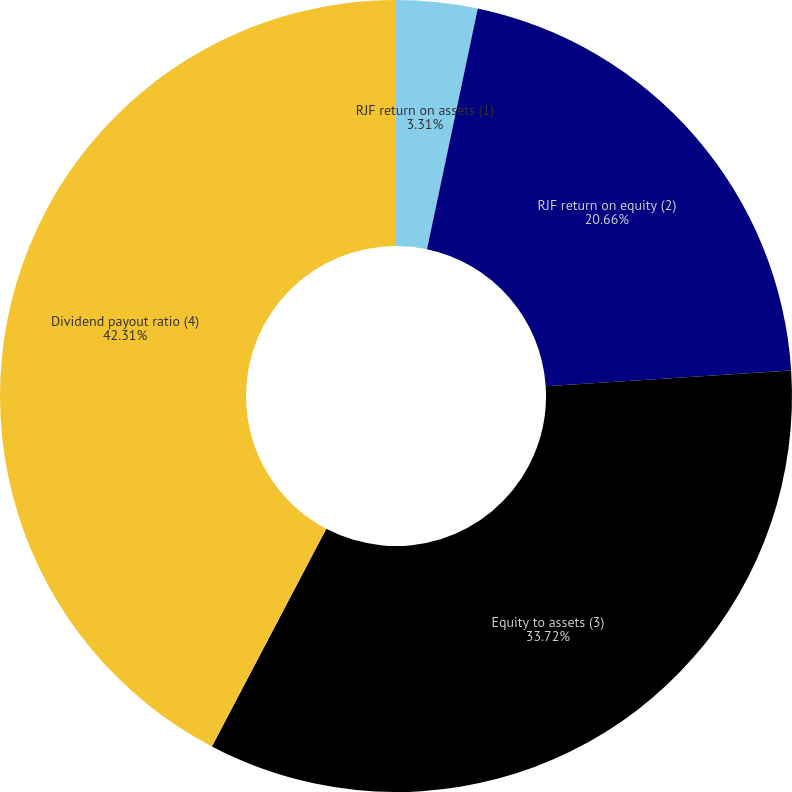Convert chart. <chart><loc_0><loc_0><loc_500><loc_500><pie_chart><fcel>RJF return on assets (1)<fcel>RJF return on equity (2)<fcel>Equity to assets (3)<fcel>Dividend payout ratio (4)<nl><fcel>3.31%<fcel>20.66%<fcel>33.72%<fcel>42.3%<nl></chart> 